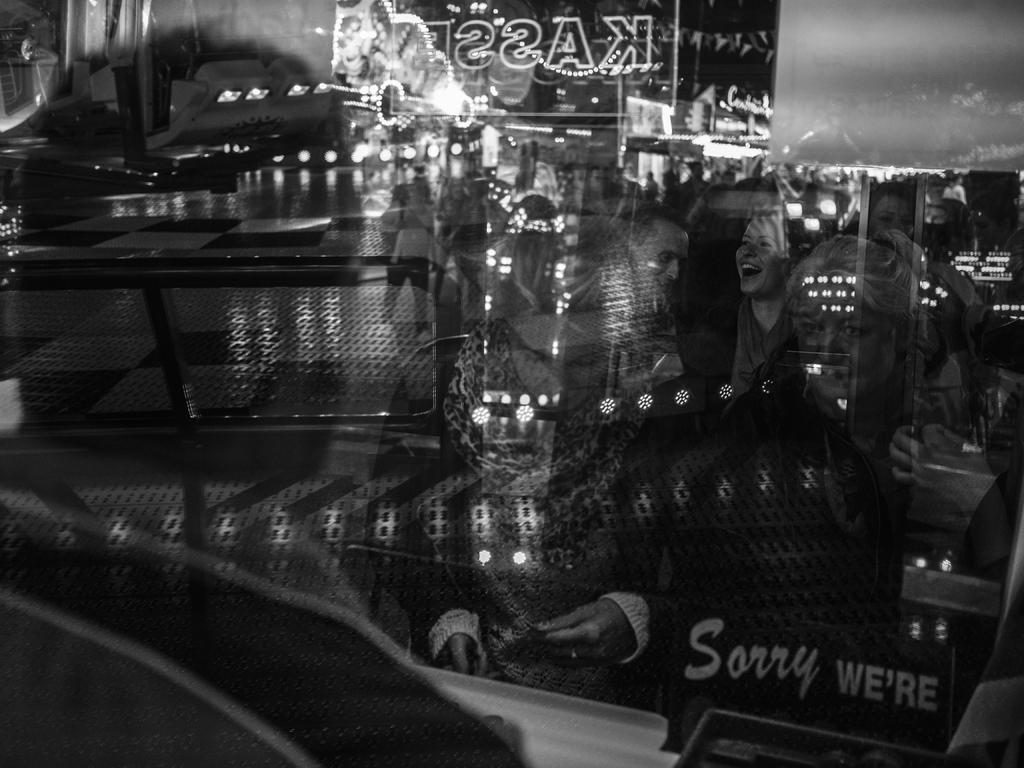What is the color scheme of the image? The image is black and white. What can be seen in the reflections in the image? There are reflections of people in the image. What else is visible in the image besides the reflections? There are lights, boards, and buildings visible in the image. What type of yam is being harvested in the image? There is no yam present in the image; it features reflections of people, lights, boards, and buildings. 